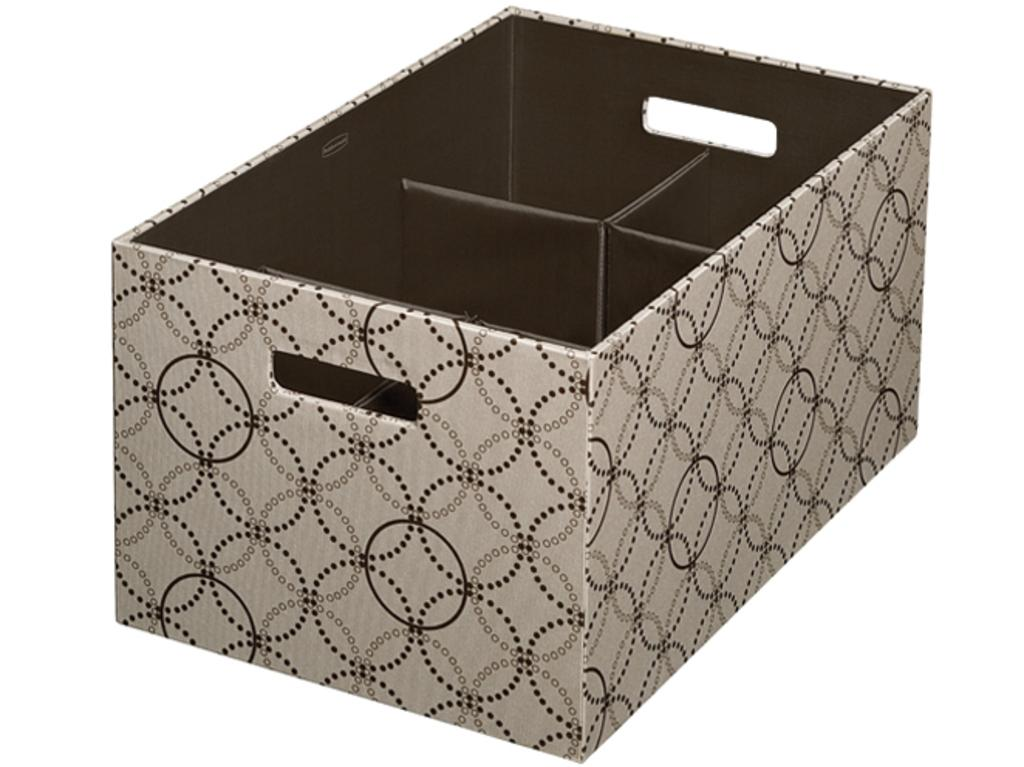What is the main object in the picture? There is a box in the picture. What colors can be seen on the box? The box has grey and brown colors. What color is the background of the image? The background of the image is white. How does the guide help the box in the image? There is no guide present in the image, so it cannot help the box. 